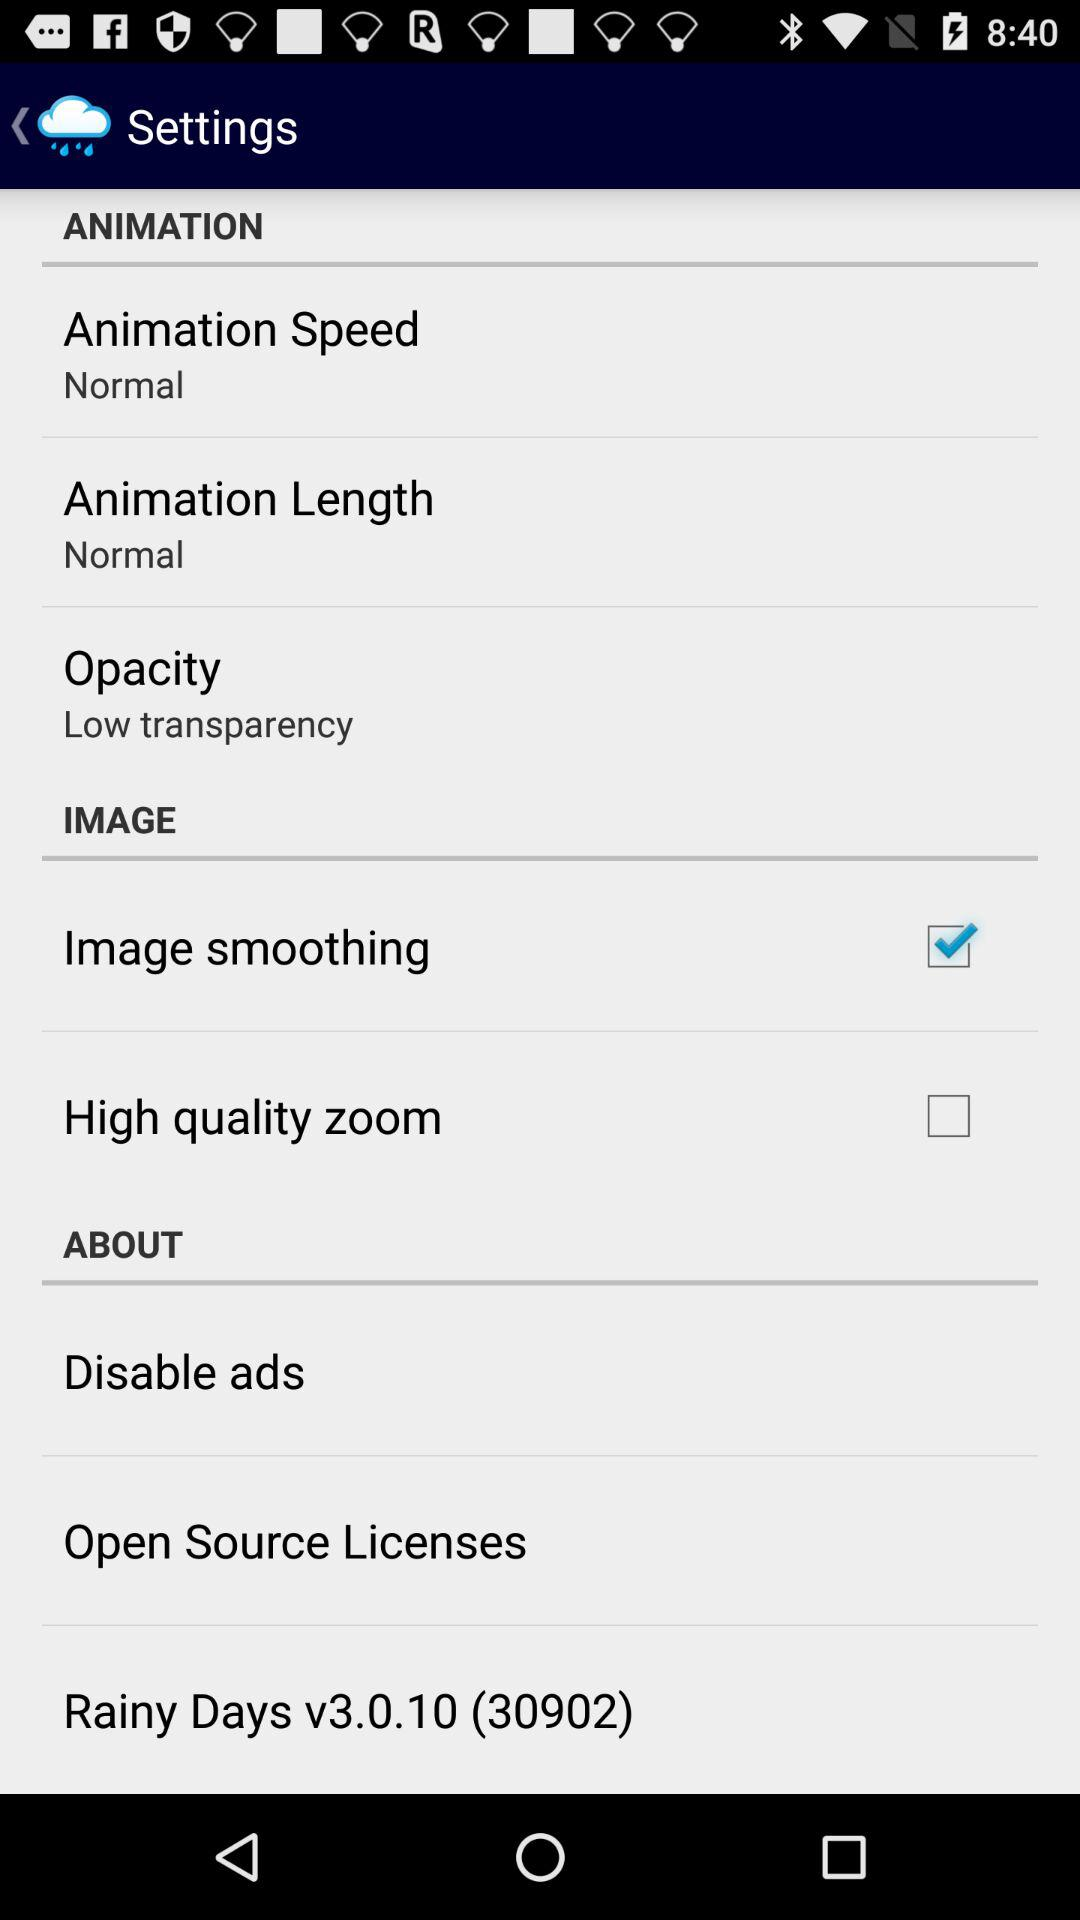What is the version of the "Rainy Days" app? The version is v3.0.10 (30902). 